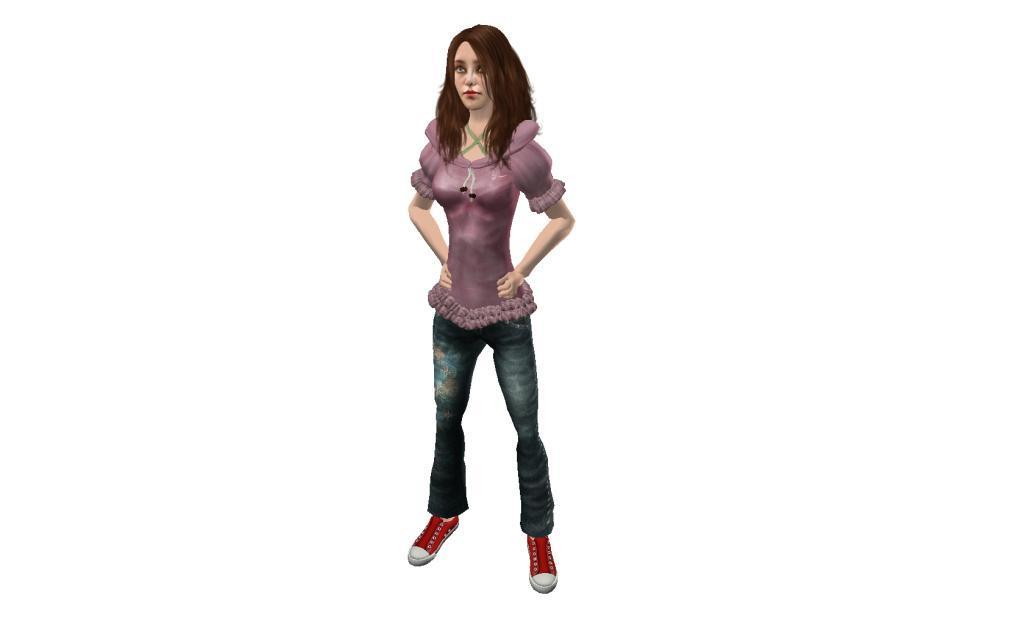What is the main subject of the image? There is a doll in the image. What type of clothing is the doll wearing? The doll is wearing jeans and a top. How many jellyfish are swimming around the doll in the image? There are no jellyfish present in the image; it features a doll wearing jeans and a top. What type of motion is the doll performing in the image? The facts provided do not mention any motion or action performed by the doll in the image. 